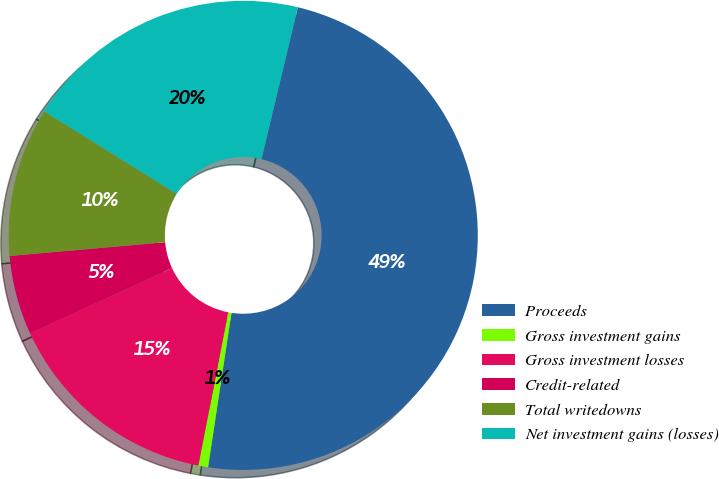<chart> <loc_0><loc_0><loc_500><loc_500><pie_chart><fcel>Proceeds<fcel>Gross investment gains<fcel>Gross investment losses<fcel>Credit-related<fcel>Total writedowns<fcel>Net investment gains (losses)<nl><fcel>48.66%<fcel>0.67%<fcel>15.07%<fcel>5.47%<fcel>10.27%<fcel>19.87%<nl></chart> 